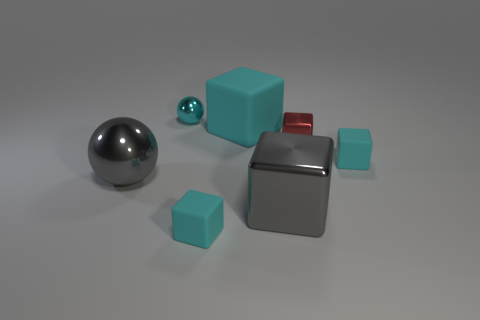Subtract all blocks. How many objects are left? 2 Subtract 1 blocks. How many blocks are left? 4 Subtract all cyan balls. Subtract all blue cylinders. How many balls are left? 1 Subtract all blue blocks. How many blue balls are left? 0 Subtract all gray shiny cubes. Subtract all gray cubes. How many objects are left? 5 Add 5 cubes. How many cubes are left? 10 Add 1 big yellow spheres. How many big yellow spheres exist? 1 Add 2 red blocks. How many objects exist? 9 Subtract all cyan balls. How many balls are left? 1 Subtract all small cyan blocks. How many blocks are left? 3 